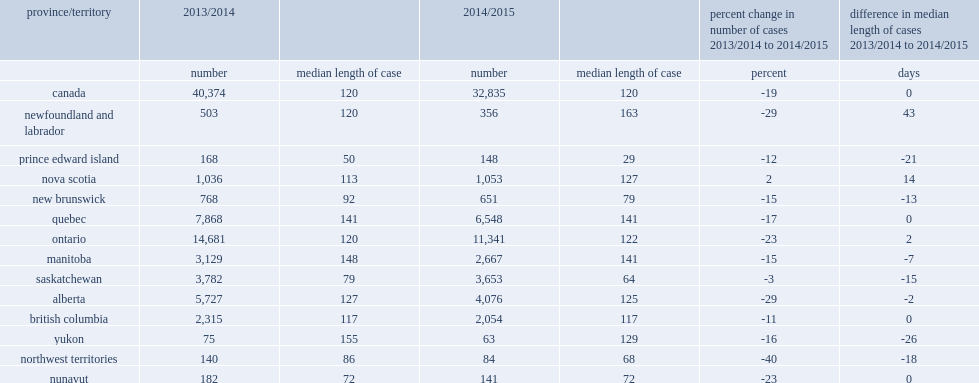Help me parse the entirety of this table. {'header': ['province/territory', '2013/2014', '', '2014/2015', '', 'percent change in number of cases 2013/2014 to 2014/2015', 'difference in median length of cases 2013/2014 to 2014/2015'], 'rows': [['', 'number', 'median length of case', 'number', 'median length of case', 'percent', 'days'], ['canada', '40,374', '120', '32,835', '120', '-19', '0'], ['newfoundland and labrador', '503', '120', '356', '163', '-29', '43'], ['prince edward island', '168', '50', '148', '29', '-12', '-21'], ['nova scotia', '1,036', '113', '1,053', '127', '2', '14'], ['new brunswick', '768', '92', '651', '79', '-15', '-13'], ['quebec', '7,868', '141', '6,548', '141', '-17', '0'], ['ontario', '14,681', '120', '11,341', '122', '-23', '2'], ['manitoba', '3,129', '148', '2,667', '141', '-15', '-7'], ['saskatchewan', '3,782', '79', '3,653', '64', '-3', '-15'], ['alberta', '5,727', '127', '4,076', '125', '-29', '-2'], ['british columbia', '2,315', '117', '2,054', '117', '-11', '0'], ['yukon', '75', '155', '63', '129', '-16', '-26'], ['northwest territories', '140', '86', '84', '68', '-40', '-18'], ['nunavut', '182', '72', '141', '72', '-23', '0']]} Decreases in the number of completed youth court cases occurred in all provinces and territories, with the exception of nova scotia, how many percent of increase? 2.0. How many percent of fewer completed youth cases in 2014/2015 compared to the previous year in ontario? 23. The northwest territories reported the largest percentage decline in the country, how many percent of decrease in the number of completed youth cases? 40. 